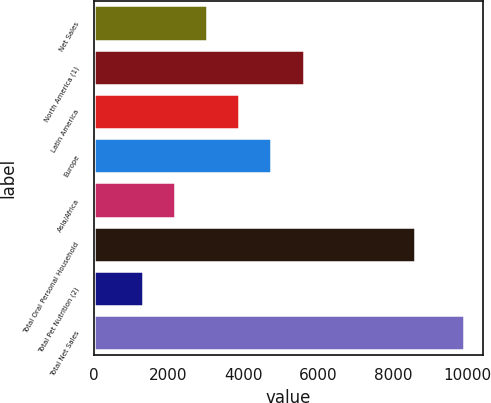<chart> <loc_0><loc_0><loc_500><loc_500><bar_chart><fcel>Net Sales<fcel>North America (1)<fcel>Latin America<fcel>Europe<fcel>Asia/Africa<fcel>Total Oral Personal Household<fcel>Total Pet Nutrition (2)<fcel>Total Net Sales<nl><fcel>3033.56<fcel>5609.75<fcel>3892.29<fcel>4751.02<fcel>2174.83<fcel>8587.3<fcel>1316.1<fcel>9903.4<nl></chart> 